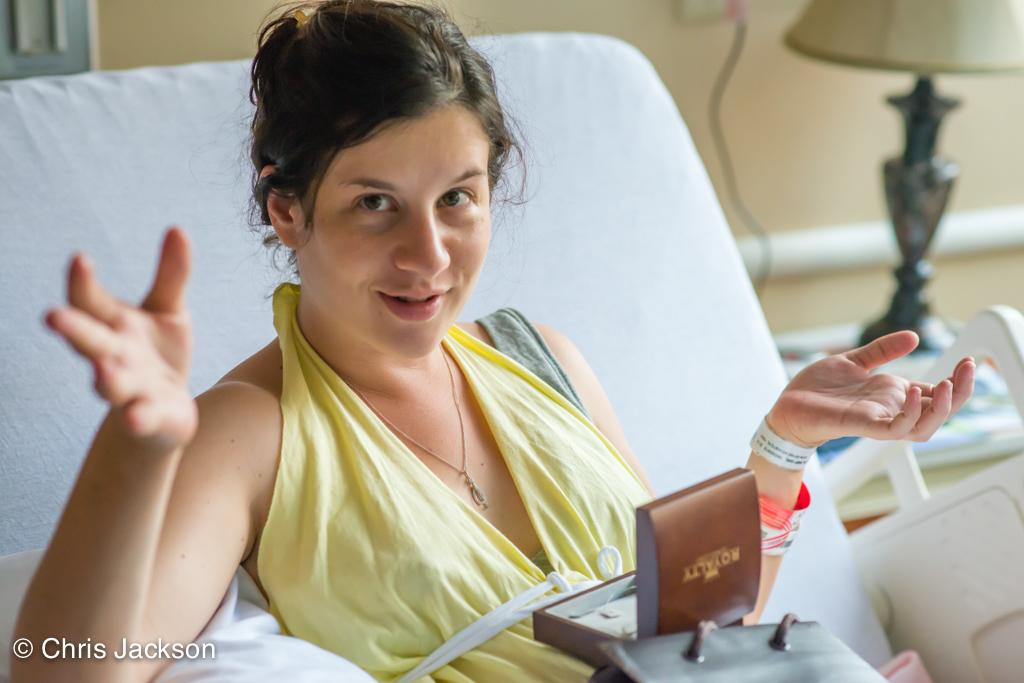Who is the main subject in the image? There is a lady in the image. What is the lady doing in the image? The lady is laying on a bed. What is the lady's facial expression or action towards the camera? The lady is looking into the camera. What objects can be seen on the lady's stomach? There are objects placed on the lady's stomach. What is the source of light in the image? There is a lamp on a table beside the bed. What type of suit is the lady wearing in the image? There is no suit visible in the image; the lady is laying on a bed and wearing objects on her stomach. 